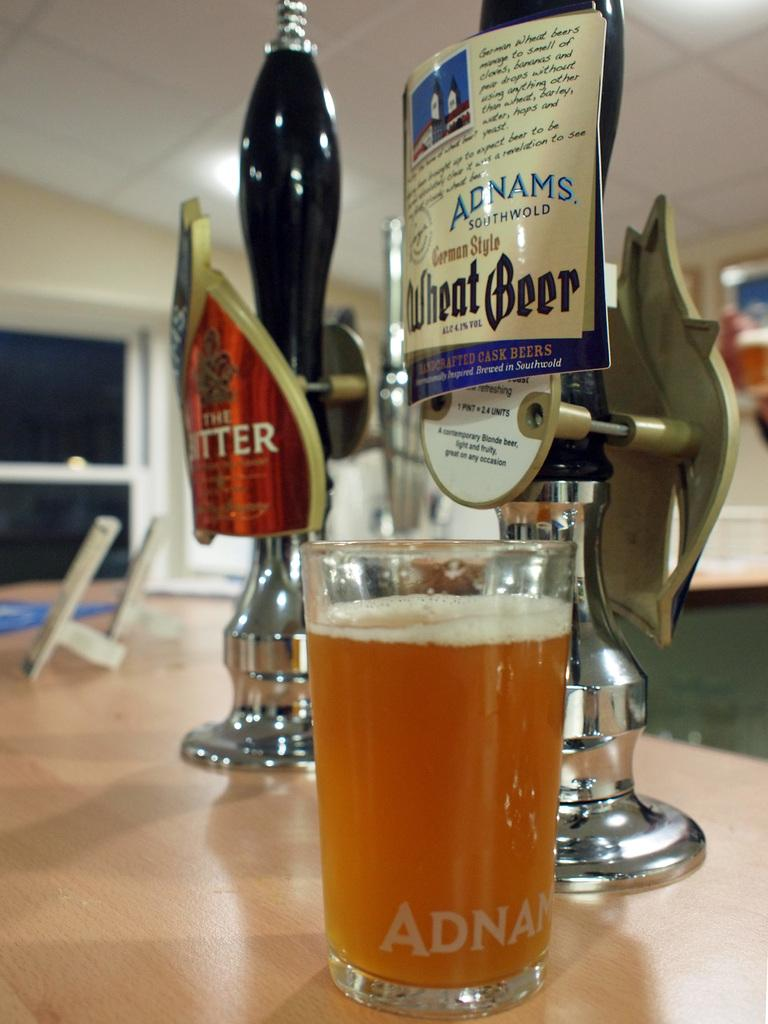<image>
Relay a brief, clear account of the picture shown. Glass of Adnams Wheat Beer in front of a tap. 